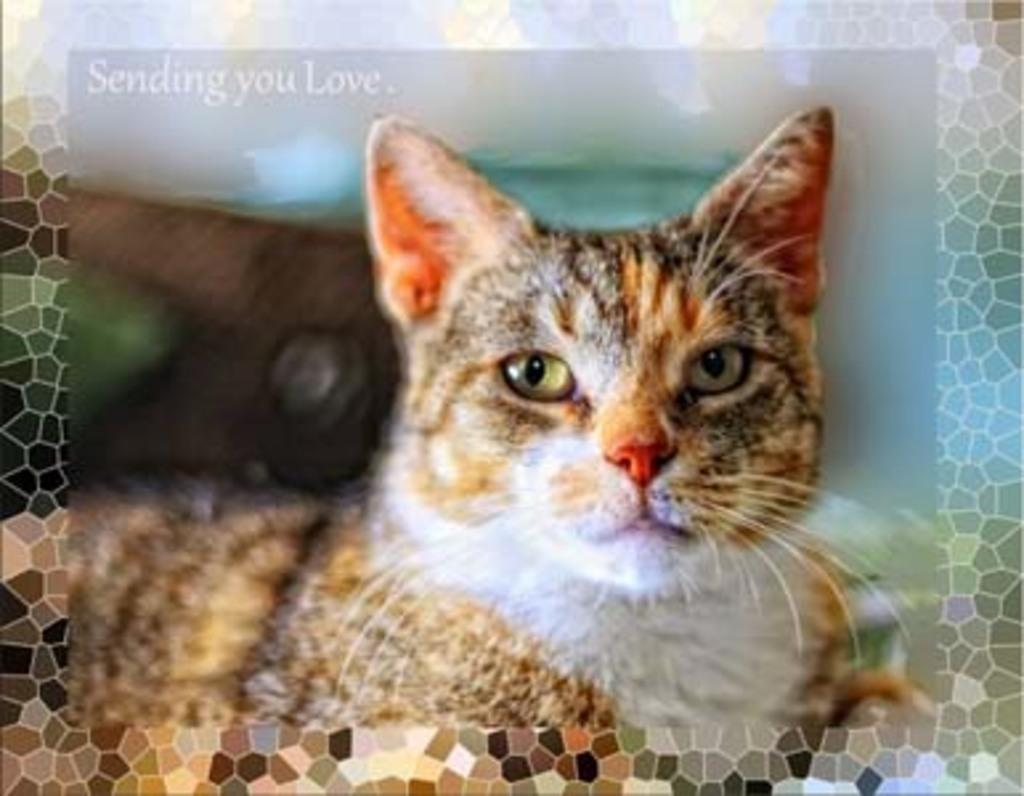What type of editing has been done to the image? The image is edited, but the specific type of editing is not mentioned in the facts. What animal can be seen in the image? There is a cat in the image. Are there any words or phrases in the image? Yes, there is text in the image. What type of flooring is visible beneath the cat in the image? There is no information about the flooring in the image, as the facts only mention the presence of a cat and text. 